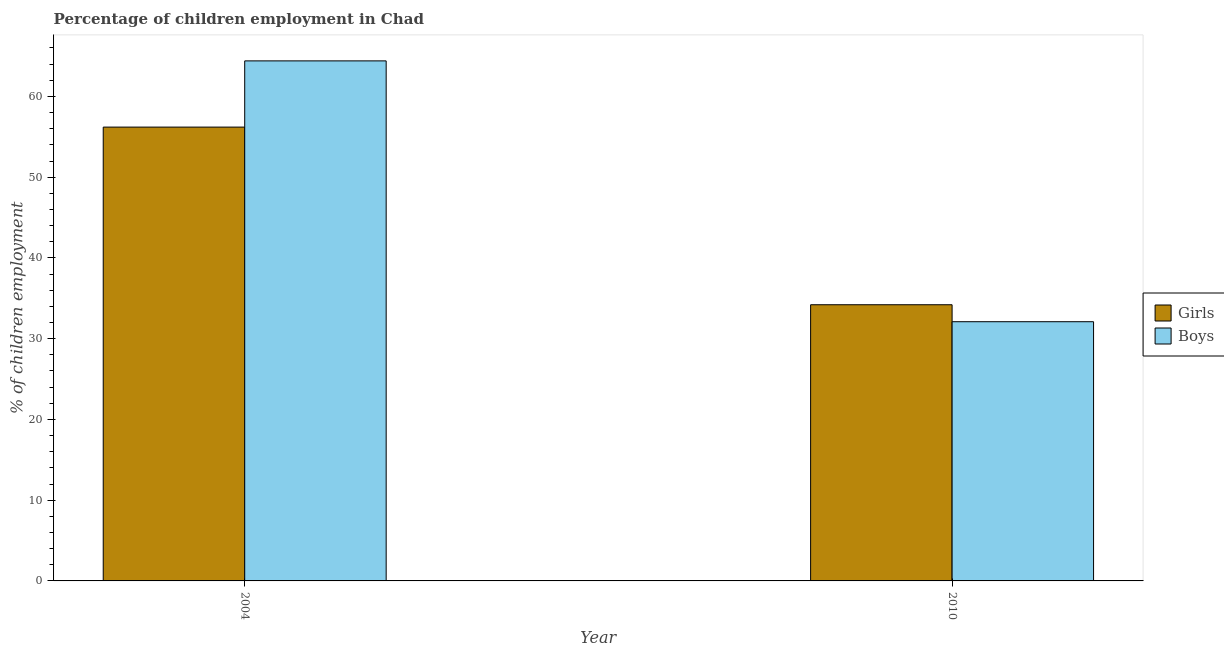Are the number of bars on each tick of the X-axis equal?
Keep it short and to the point. Yes. How many bars are there on the 2nd tick from the right?
Your response must be concise. 2. What is the percentage of employed girls in 2010?
Provide a succinct answer. 34.2. Across all years, what is the maximum percentage of employed girls?
Your response must be concise. 56.2. Across all years, what is the minimum percentage of employed boys?
Make the answer very short. 32.1. In which year was the percentage of employed boys maximum?
Provide a short and direct response. 2004. In which year was the percentage of employed boys minimum?
Make the answer very short. 2010. What is the total percentage of employed girls in the graph?
Provide a short and direct response. 90.4. What is the difference between the percentage of employed girls in 2004 and that in 2010?
Provide a short and direct response. 22. What is the average percentage of employed girls per year?
Your answer should be compact. 45.2. In the year 2004, what is the difference between the percentage of employed girls and percentage of employed boys?
Offer a very short reply. 0. In how many years, is the percentage of employed boys greater than 14 %?
Your response must be concise. 2. What is the ratio of the percentage of employed girls in 2004 to that in 2010?
Keep it short and to the point. 1.64. In how many years, is the percentage of employed boys greater than the average percentage of employed boys taken over all years?
Make the answer very short. 1. What does the 1st bar from the left in 2004 represents?
Ensure brevity in your answer.  Girls. What does the 1st bar from the right in 2010 represents?
Give a very brief answer. Boys. How many years are there in the graph?
Your response must be concise. 2. Does the graph contain any zero values?
Ensure brevity in your answer.  No. Where does the legend appear in the graph?
Provide a succinct answer. Center right. How many legend labels are there?
Your answer should be very brief. 2. What is the title of the graph?
Offer a terse response. Percentage of children employment in Chad. What is the label or title of the X-axis?
Provide a short and direct response. Year. What is the label or title of the Y-axis?
Give a very brief answer. % of children employment. What is the % of children employment in Girls in 2004?
Keep it short and to the point. 56.2. What is the % of children employment of Boys in 2004?
Ensure brevity in your answer.  64.4. What is the % of children employment in Girls in 2010?
Make the answer very short. 34.2. What is the % of children employment of Boys in 2010?
Your response must be concise. 32.1. Across all years, what is the maximum % of children employment in Girls?
Provide a short and direct response. 56.2. Across all years, what is the maximum % of children employment of Boys?
Your response must be concise. 64.4. Across all years, what is the minimum % of children employment of Girls?
Ensure brevity in your answer.  34.2. Across all years, what is the minimum % of children employment of Boys?
Keep it short and to the point. 32.1. What is the total % of children employment in Girls in the graph?
Provide a succinct answer. 90.4. What is the total % of children employment of Boys in the graph?
Your answer should be very brief. 96.5. What is the difference between the % of children employment of Girls in 2004 and that in 2010?
Offer a very short reply. 22. What is the difference between the % of children employment of Boys in 2004 and that in 2010?
Ensure brevity in your answer.  32.3. What is the difference between the % of children employment of Girls in 2004 and the % of children employment of Boys in 2010?
Offer a terse response. 24.1. What is the average % of children employment in Girls per year?
Provide a succinct answer. 45.2. What is the average % of children employment in Boys per year?
Your answer should be compact. 48.25. What is the ratio of the % of children employment in Girls in 2004 to that in 2010?
Offer a terse response. 1.64. What is the ratio of the % of children employment of Boys in 2004 to that in 2010?
Keep it short and to the point. 2.01. What is the difference between the highest and the second highest % of children employment in Boys?
Your answer should be very brief. 32.3. What is the difference between the highest and the lowest % of children employment of Boys?
Offer a terse response. 32.3. 